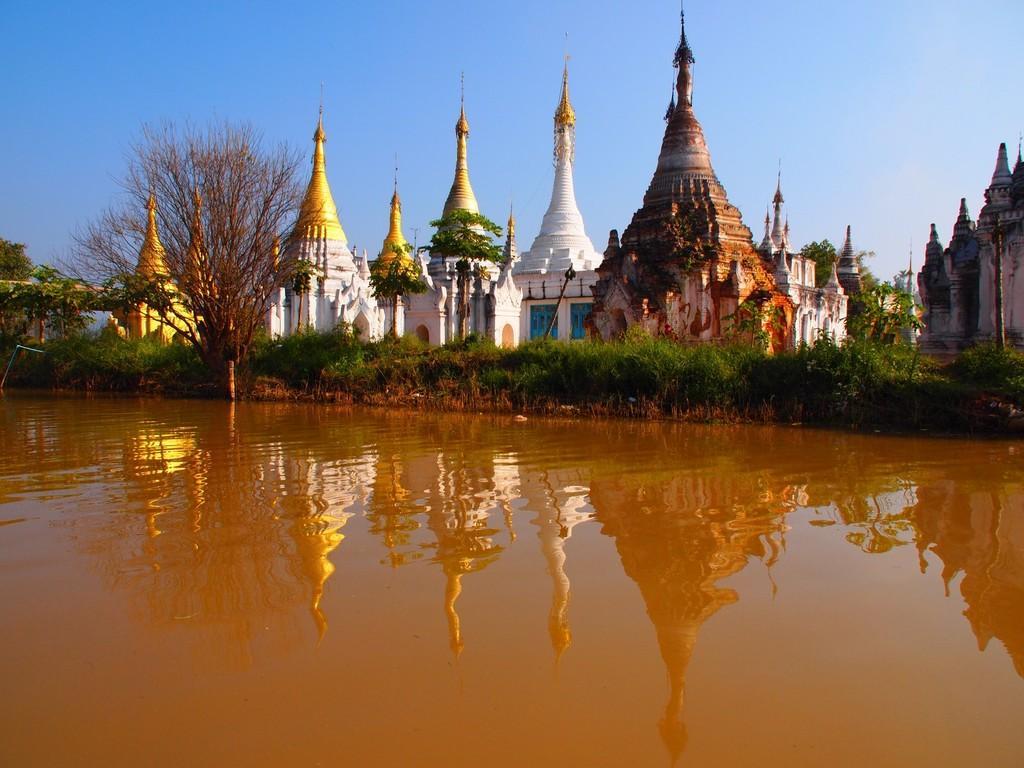Could you give a brief overview of what you see in this image? This picture is clicked outside. In the foreground we can see a water body. In the center we can see the plants and trees and we can see the buildings and the spires like objects. In the background we can see the sky, trees and some other objects. 